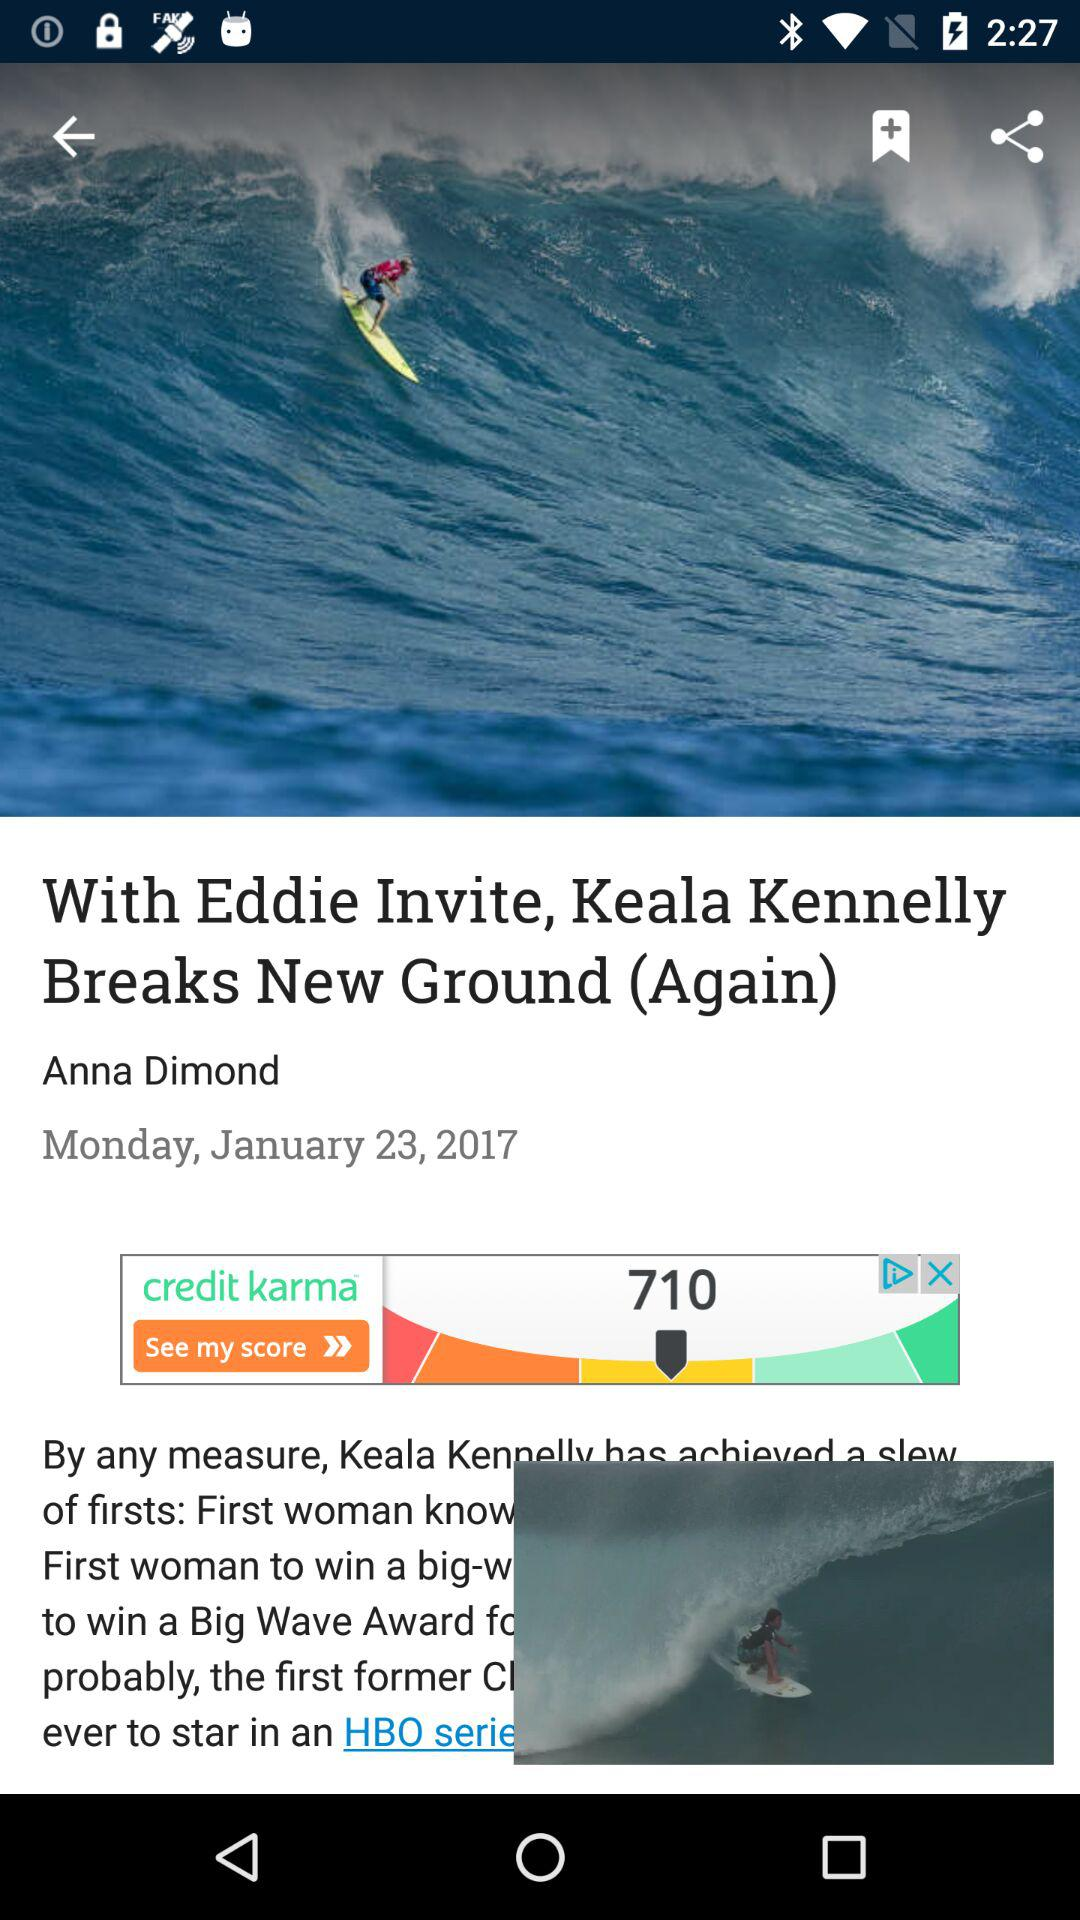What is the published date? The published date is Monday, January 23, 2017. 